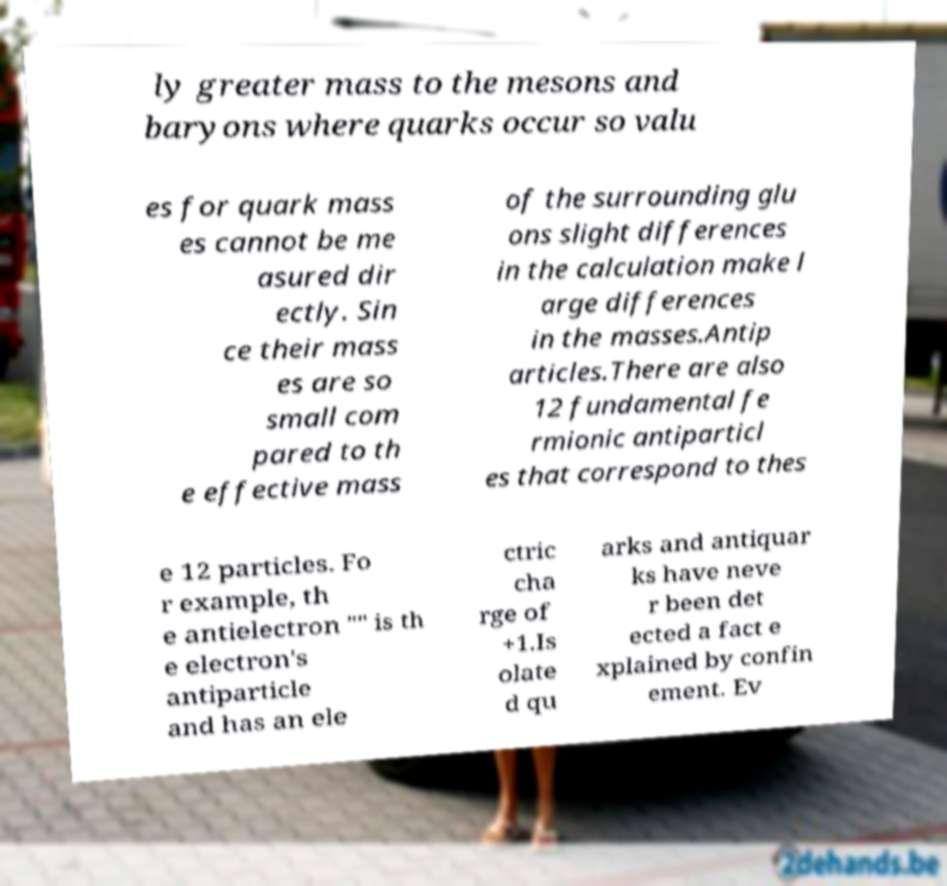Could you extract and type out the text from this image? ly greater mass to the mesons and baryons where quarks occur so valu es for quark mass es cannot be me asured dir ectly. Sin ce their mass es are so small com pared to th e effective mass of the surrounding glu ons slight differences in the calculation make l arge differences in the masses.Antip articles.There are also 12 fundamental fe rmionic antiparticl es that correspond to thes e 12 particles. Fo r example, th e antielectron "" is th e electron's antiparticle and has an ele ctric cha rge of +1.Is olate d qu arks and antiquar ks have neve r been det ected a fact e xplained by confin ement. Ev 